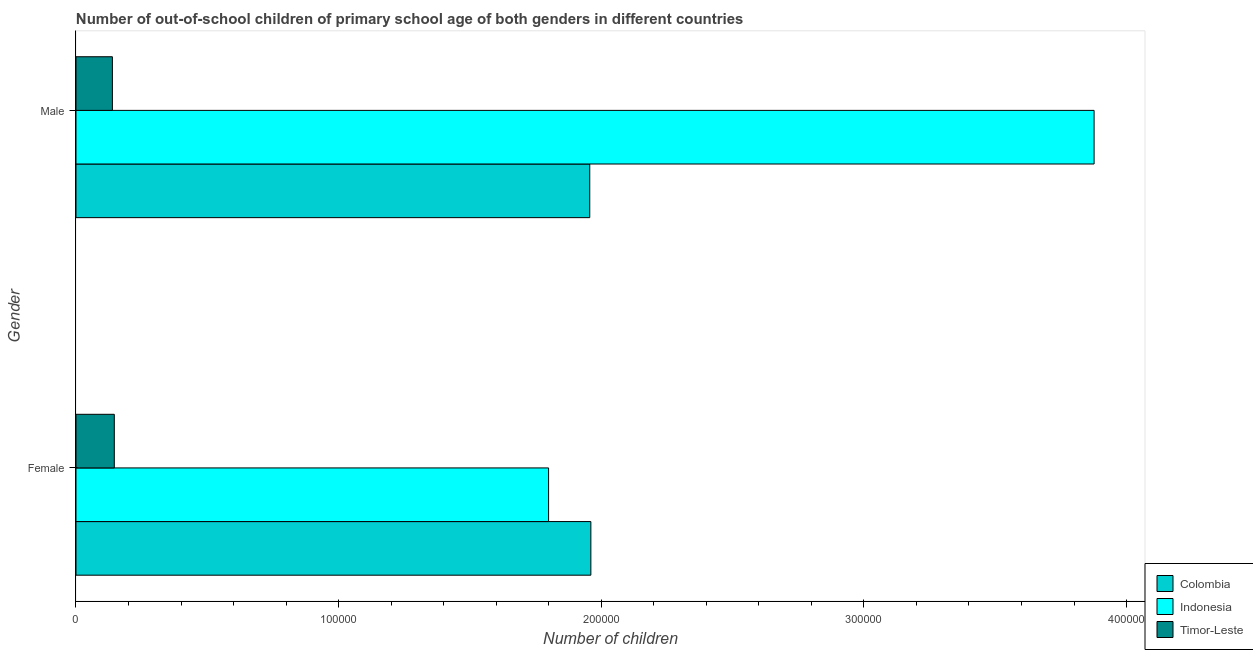Are the number of bars on each tick of the Y-axis equal?
Make the answer very short. Yes. What is the number of female out-of-school students in Colombia?
Provide a succinct answer. 1.96e+05. Across all countries, what is the maximum number of female out-of-school students?
Make the answer very short. 1.96e+05. Across all countries, what is the minimum number of male out-of-school students?
Keep it short and to the point. 1.39e+04. In which country was the number of female out-of-school students maximum?
Make the answer very short. Colombia. In which country was the number of male out-of-school students minimum?
Give a very brief answer. Timor-Leste. What is the total number of female out-of-school students in the graph?
Provide a succinct answer. 3.91e+05. What is the difference between the number of male out-of-school students in Colombia and that in Indonesia?
Ensure brevity in your answer.  -1.92e+05. What is the difference between the number of female out-of-school students in Indonesia and the number of male out-of-school students in Timor-Leste?
Offer a terse response. 1.66e+05. What is the average number of female out-of-school students per country?
Your response must be concise. 1.30e+05. What is the difference between the number of male out-of-school students and number of female out-of-school students in Timor-Leste?
Give a very brief answer. -725. In how many countries, is the number of male out-of-school students greater than 60000 ?
Provide a short and direct response. 2. What is the ratio of the number of male out-of-school students in Timor-Leste to that in Colombia?
Your answer should be compact. 0.07. Is the number of female out-of-school students in Timor-Leste less than that in Indonesia?
Your answer should be compact. Yes. What does the 1st bar from the top in Male represents?
Give a very brief answer. Timor-Leste. What does the 3rd bar from the bottom in Male represents?
Offer a terse response. Timor-Leste. Are all the bars in the graph horizontal?
Offer a terse response. Yes. How many countries are there in the graph?
Make the answer very short. 3. Does the graph contain any zero values?
Ensure brevity in your answer.  No. Does the graph contain grids?
Offer a terse response. No. How many legend labels are there?
Your response must be concise. 3. What is the title of the graph?
Your answer should be compact. Number of out-of-school children of primary school age of both genders in different countries. What is the label or title of the X-axis?
Provide a succinct answer. Number of children. What is the label or title of the Y-axis?
Your answer should be compact. Gender. What is the Number of children of Colombia in Female?
Offer a terse response. 1.96e+05. What is the Number of children in Indonesia in Female?
Provide a succinct answer. 1.80e+05. What is the Number of children in Timor-Leste in Female?
Your answer should be very brief. 1.46e+04. What is the Number of children in Colombia in Male?
Your answer should be compact. 1.96e+05. What is the Number of children of Indonesia in Male?
Offer a terse response. 3.88e+05. What is the Number of children in Timor-Leste in Male?
Keep it short and to the point. 1.39e+04. Across all Gender, what is the maximum Number of children in Colombia?
Your answer should be compact. 1.96e+05. Across all Gender, what is the maximum Number of children of Indonesia?
Your response must be concise. 3.88e+05. Across all Gender, what is the maximum Number of children in Timor-Leste?
Offer a terse response. 1.46e+04. Across all Gender, what is the minimum Number of children of Colombia?
Your answer should be very brief. 1.96e+05. Across all Gender, what is the minimum Number of children of Indonesia?
Ensure brevity in your answer.  1.80e+05. Across all Gender, what is the minimum Number of children of Timor-Leste?
Your answer should be compact. 1.39e+04. What is the total Number of children in Colombia in the graph?
Your response must be concise. 3.92e+05. What is the total Number of children in Indonesia in the graph?
Provide a succinct answer. 5.68e+05. What is the total Number of children in Timor-Leste in the graph?
Offer a very short reply. 2.84e+04. What is the difference between the Number of children of Colombia in Female and that in Male?
Provide a succinct answer. 418. What is the difference between the Number of children of Indonesia in Female and that in Male?
Make the answer very short. -2.08e+05. What is the difference between the Number of children in Timor-Leste in Female and that in Male?
Keep it short and to the point. 725. What is the difference between the Number of children in Colombia in Female and the Number of children in Indonesia in Male?
Offer a terse response. -1.92e+05. What is the difference between the Number of children of Colombia in Female and the Number of children of Timor-Leste in Male?
Make the answer very short. 1.82e+05. What is the difference between the Number of children in Indonesia in Female and the Number of children in Timor-Leste in Male?
Your answer should be very brief. 1.66e+05. What is the average Number of children of Colombia per Gender?
Make the answer very short. 1.96e+05. What is the average Number of children of Indonesia per Gender?
Your answer should be very brief. 2.84e+05. What is the average Number of children of Timor-Leste per Gender?
Your answer should be very brief. 1.42e+04. What is the difference between the Number of children in Colombia and Number of children in Indonesia in Female?
Make the answer very short. 1.61e+04. What is the difference between the Number of children of Colombia and Number of children of Timor-Leste in Female?
Your response must be concise. 1.81e+05. What is the difference between the Number of children in Indonesia and Number of children in Timor-Leste in Female?
Give a very brief answer. 1.65e+05. What is the difference between the Number of children in Colombia and Number of children in Indonesia in Male?
Ensure brevity in your answer.  -1.92e+05. What is the difference between the Number of children in Colombia and Number of children in Timor-Leste in Male?
Provide a succinct answer. 1.82e+05. What is the difference between the Number of children in Indonesia and Number of children in Timor-Leste in Male?
Your answer should be compact. 3.74e+05. What is the ratio of the Number of children in Colombia in Female to that in Male?
Give a very brief answer. 1. What is the ratio of the Number of children in Indonesia in Female to that in Male?
Keep it short and to the point. 0.46. What is the ratio of the Number of children of Timor-Leste in Female to that in Male?
Ensure brevity in your answer.  1.05. What is the difference between the highest and the second highest Number of children in Colombia?
Your answer should be compact. 418. What is the difference between the highest and the second highest Number of children in Indonesia?
Provide a succinct answer. 2.08e+05. What is the difference between the highest and the second highest Number of children in Timor-Leste?
Provide a succinct answer. 725. What is the difference between the highest and the lowest Number of children in Colombia?
Ensure brevity in your answer.  418. What is the difference between the highest and the lowest Number of children in Indonesia?
Give a very brief answer. 2.08e+05. What is the difference between the highest and the lowest Number of children of Timor-Leste?
Offer a very short reply. 725. 